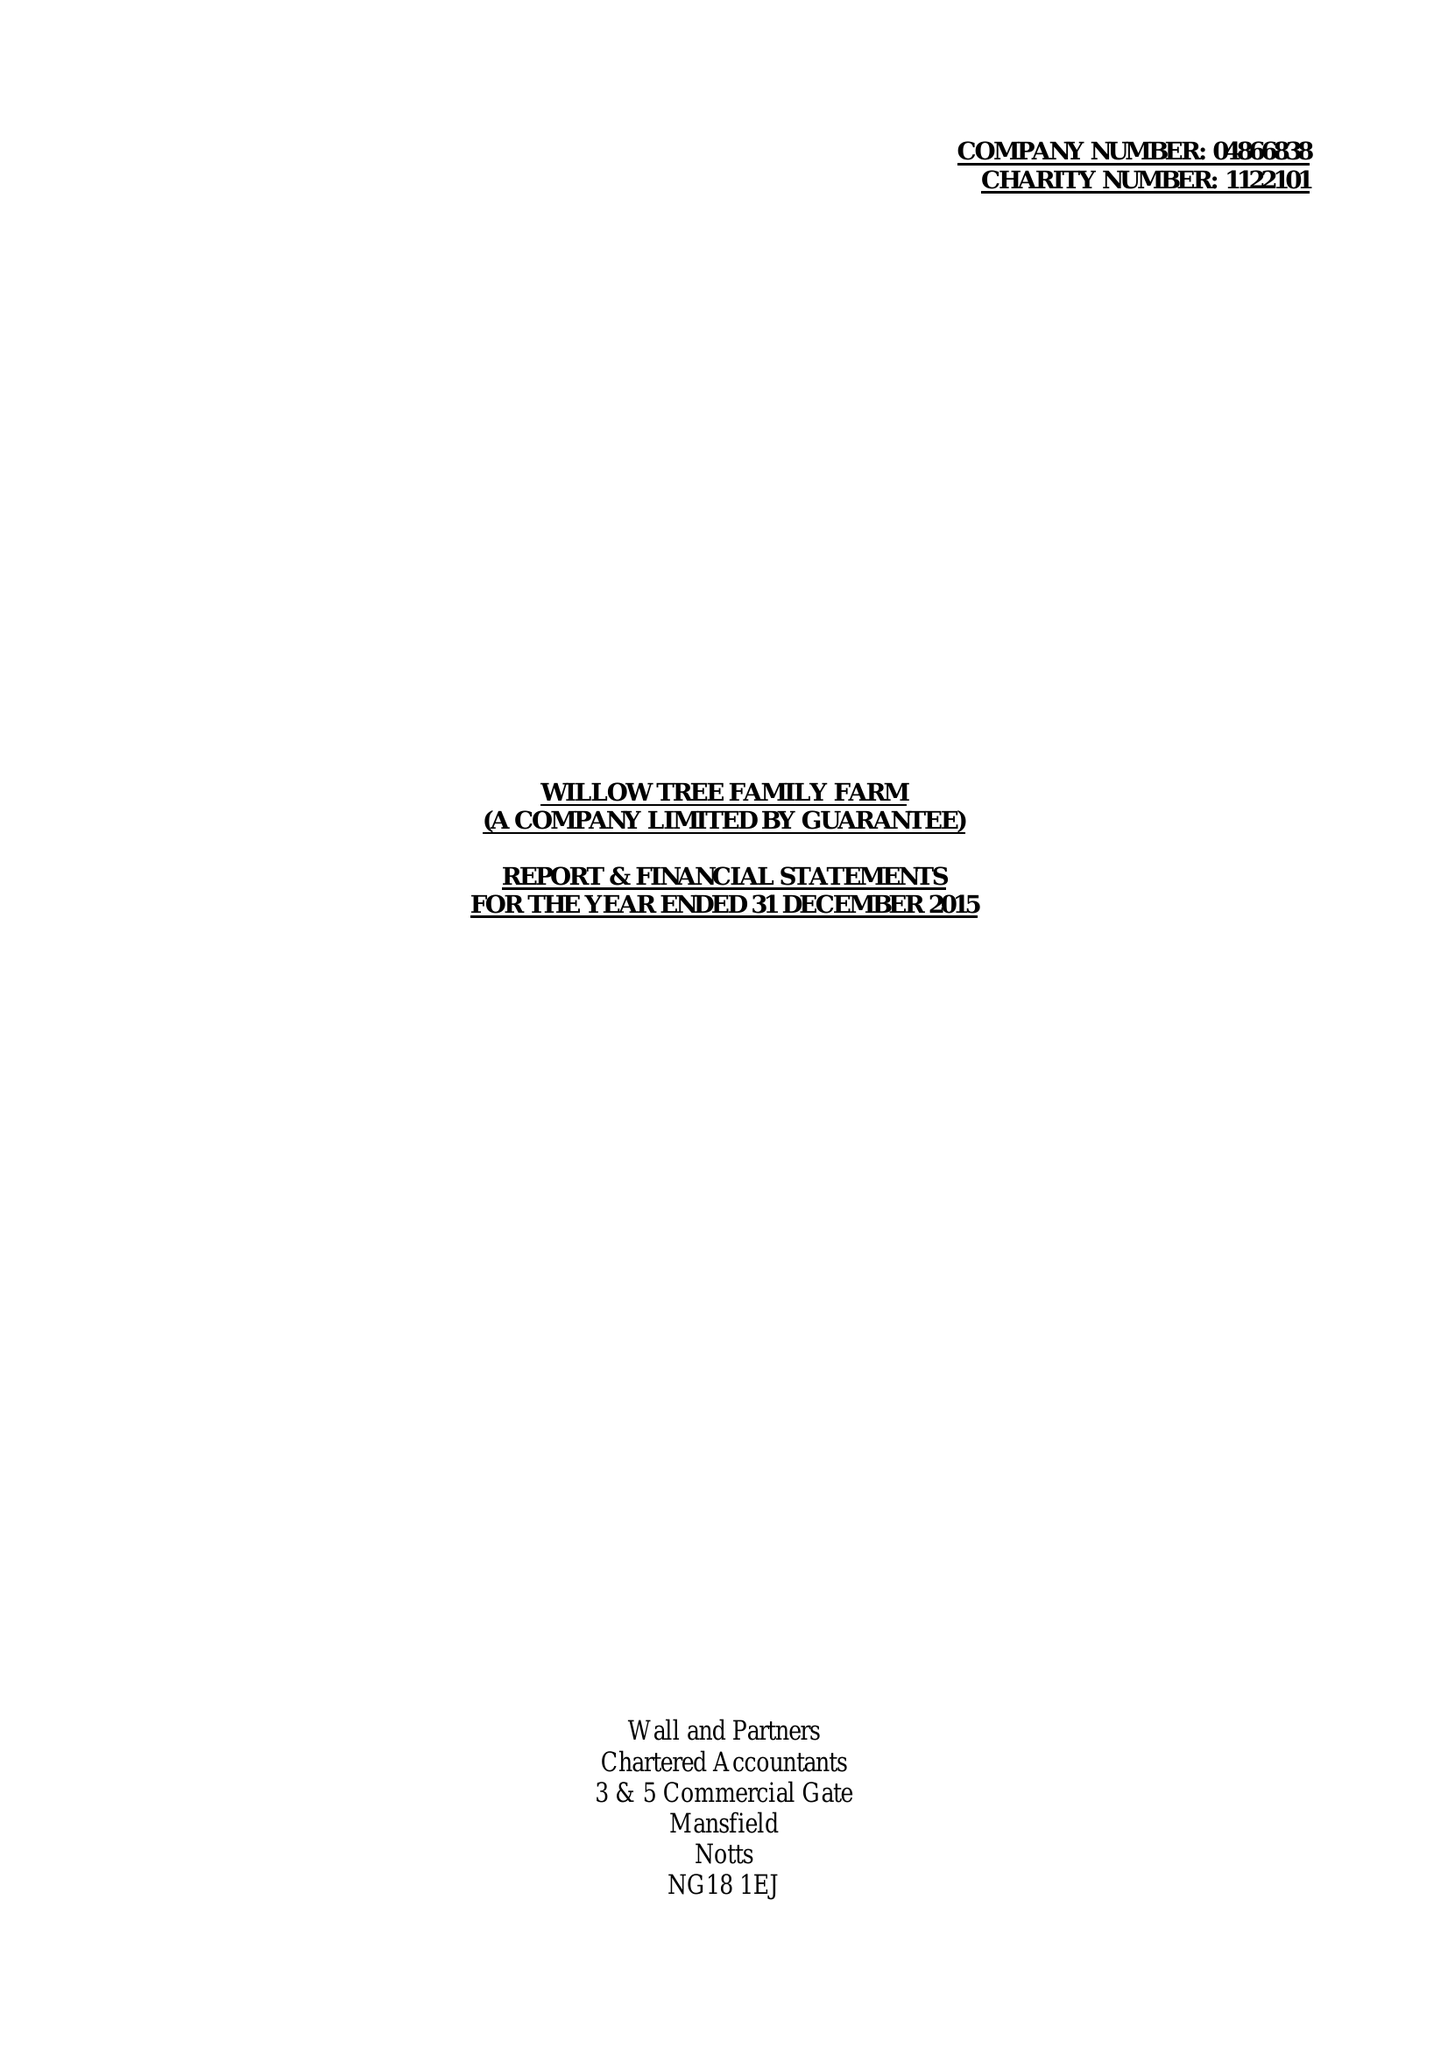What is the value for the address__post_town?
Answer the question using a single word or phrase. MANSFIELD 